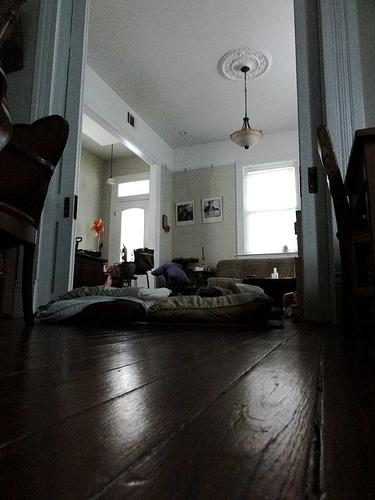Mention three decorative elements present in the image. Artwork hanging on the wall, pillows on the floor, and a ceiling medallion around the light fixture. List five key objects you can see in the image. Hardwood floor, window with blinds, light fixtures on the ceiling, pillows on the floor, artwork on the wall. Mention the different light sources present in the image. There are several light sources, including a window letting in natural light, a ceiling light, and a small hanging light fixture. Summarize the atmosphere of the room depicted in the image. The room has a warm and inviting atmosphere with natural light, comfortable furnishings, and aesthetically pleasing decor. Highlight any noticeable items placed on the floor in the image. There are large pillows and dog beds placed on the hardwood floor, creating a cozy and welcoming environment. Briefly describe the window and its surroundings in the image. The window is rectangular, covered with blinds, and letting in natural light, it is surrounded by wall art and a sliding glass door. Describe the color scheme of the room displayed in the image. The room has a neutral color palette, featuring white walls and ceiling, a dark brown wooden floor, and pops of color added by decorative elements like pillows and artwork. Describe the environment depicted in the image. The image portrays an elegantly designed living room with a natural wood floor, white walls and ceiling, and light streaming in through a window. Describe the floor and the furnishings in the image. The floor is a polished hardwood with a glossy finish, and the room is furnished with a sofa, dining chair, pillows, and wall art. Provide a brief overview of the elements present in the image. The image shows a living room with hardwood flooring, white walls, a window, a ceiling light, a sofa, pillows, and wall art. 